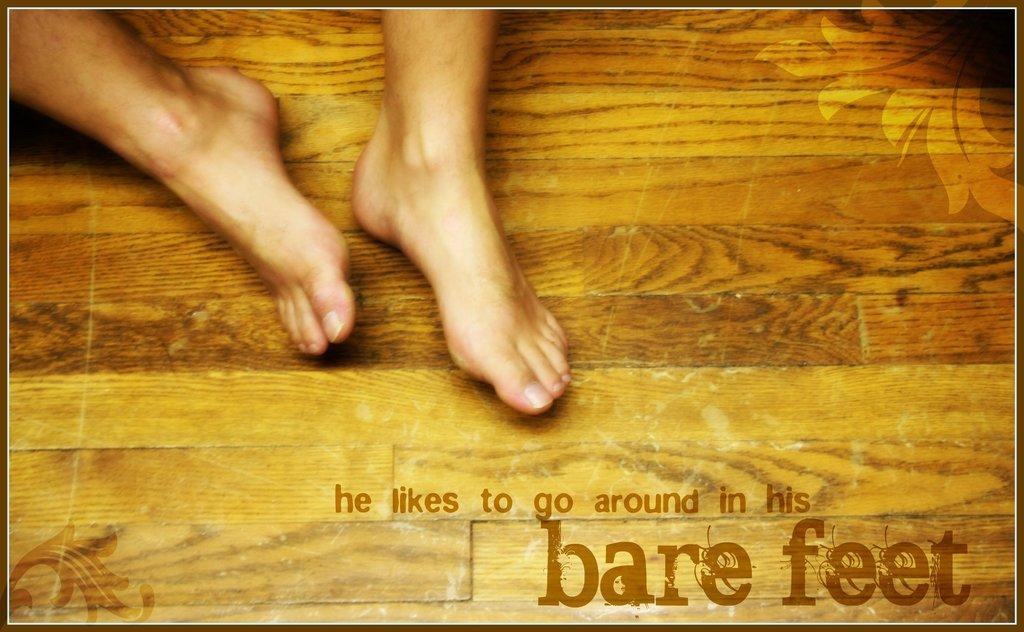What does he like to go around in?
Offer a very short reply. Bare feet. What body part is showing here?
Give a very brief answer. Feet. 